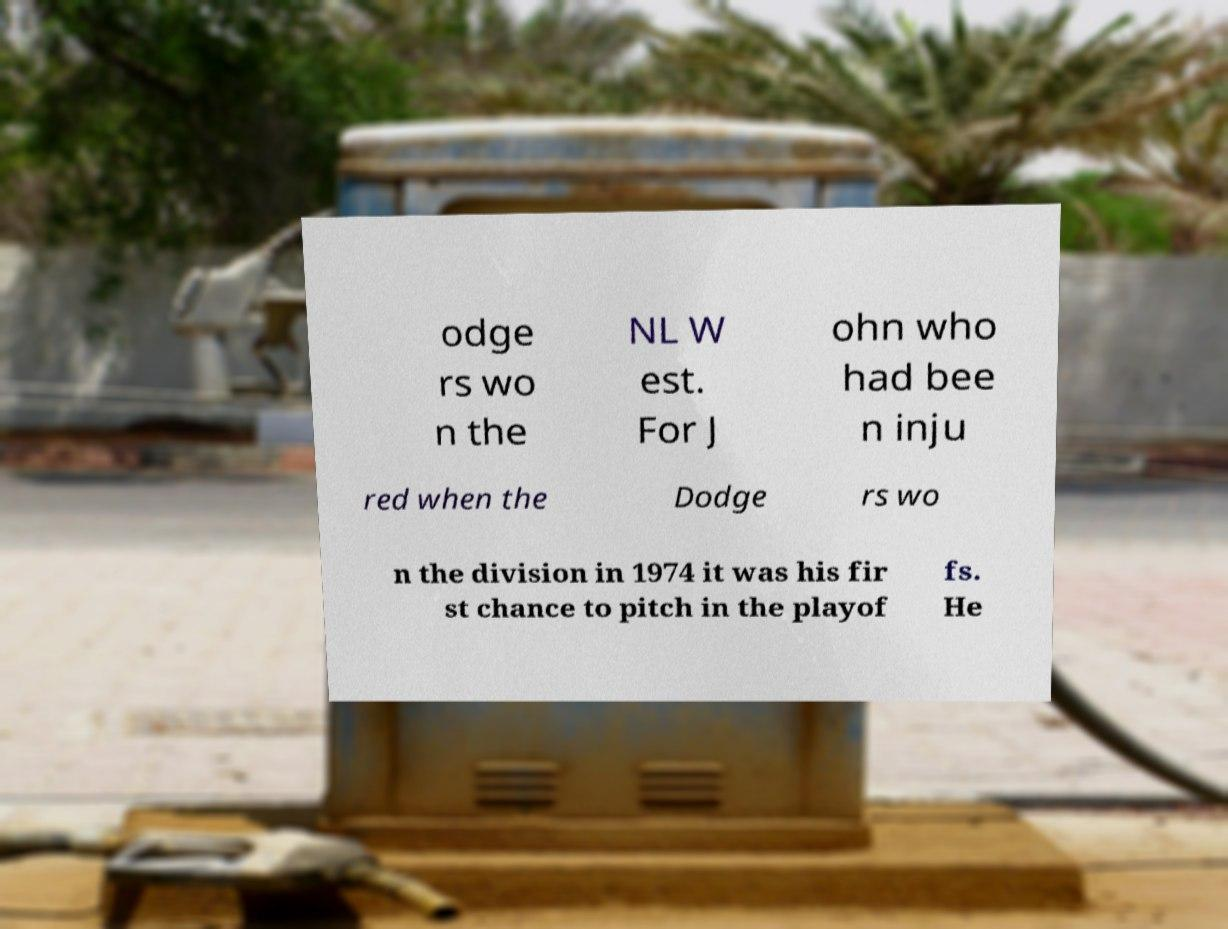I need the written content from this picture converted into text. Can you do that? odge rs wo n the NL W est. For J ohn who had bee n inju red when the Dodge rs wo n the division in 1974 it was his fir st chance to pitch in the playof fs. He 